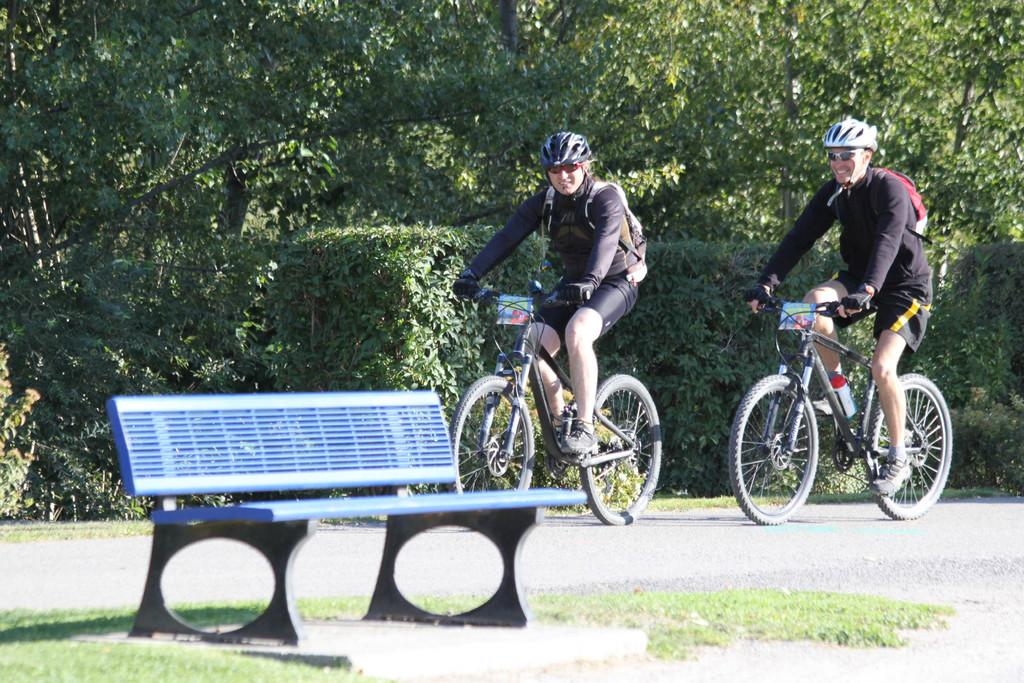How many people are in the image? There are two persons in the image. What are the persons wearing on their heads? Both persons are wearing helmets. What else are the persons wearing? Both persons are wearing glasses. What are the persons doing in the image? The persons are riding bicycles. Where are the bicycles located? The bicycles are on the road. What can be seen in the background of the image? There is a bench, grass, and trees in the background of the image. What type of dress is the goldfish wearing in the image? There is no goldfish present in the image, and therefore no dress or any other clothing item can be observed. 